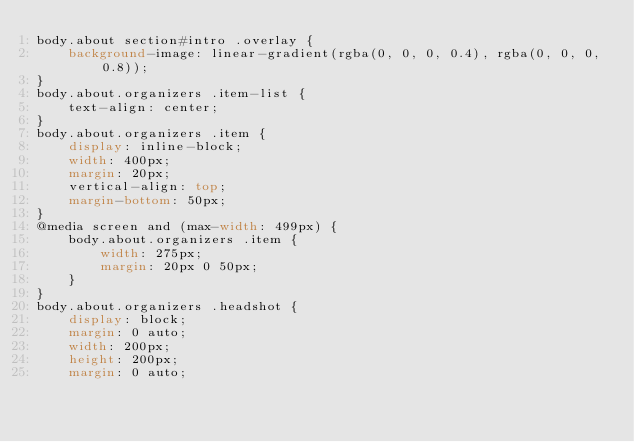<code> <loc_0><loc_0><loc_500><loc_500><_CSS_>body.about section#intro .overlay {
    background-image: linear-gradient(rgba(0, 0, 0, 0.4), rgba(0, 0, 0, 0.8));
}
body.about.organizers .item-list {
    text-align: center;
}
body.about.organizers .item {
    display: inline-block;
    width: 400px;
    margin: 20px;
    vertical-align: top;
    margin-bottom: 50px;
}
@media screen and (max-width: 499px) {
    body.about.organizers .item {
        width: 275px;
        margin: 20px 0 50px;
    }
}
body.about.organizers .headshot {
    display: block;
    margin: 0 auto;
    width: 200px;
    height: 200px;
    margin: 0 auto;</code> 